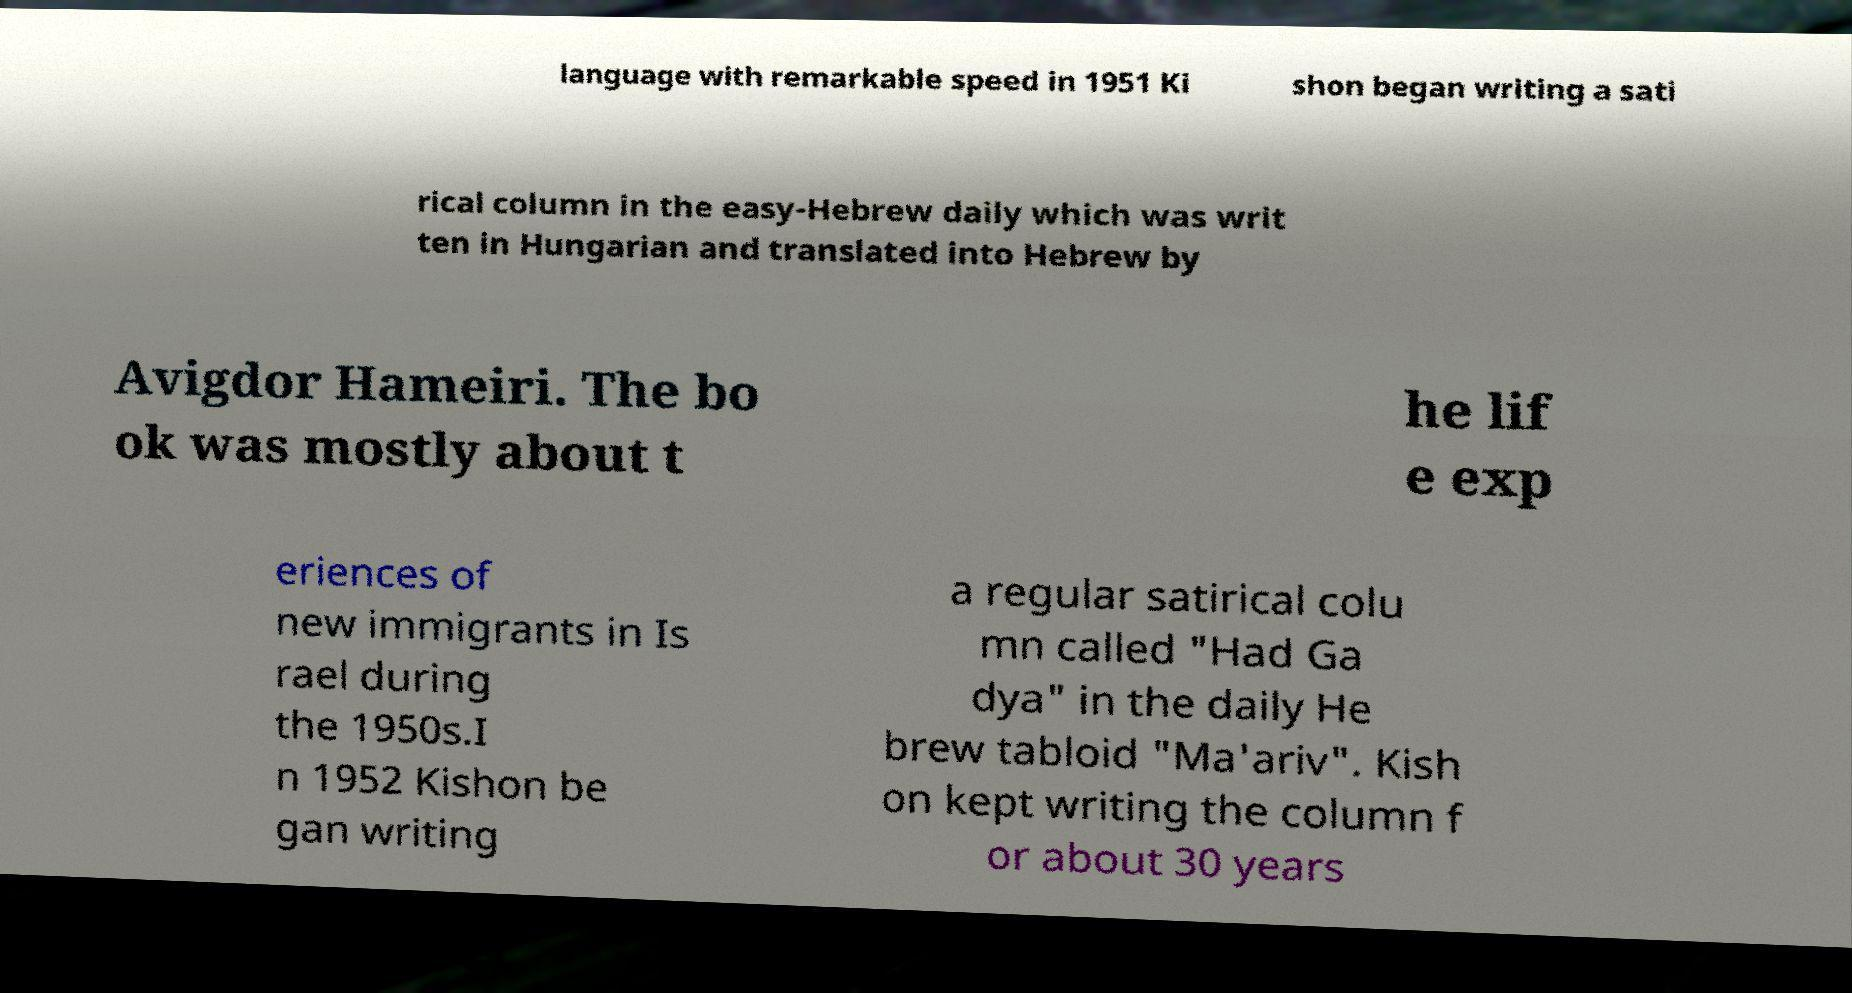What messages or text are displayed in this image? I need them in a readable, typed format. language with remarkable speed in 1951 Ki shon began writing a sati rical column in the easy-Hebrew daily which was writ ten in Hungarian and translated into Hebrew by Avigdor Hameiri. The bo ok was mostly about t he lif e exp eriences of new immigrants in Is rael during the 1950s.I n 1952 Kishon be gan writing a regular satirical colu mn called "Had Ga dya" in the daily He brew tabloid "Ma'ariv". Kish on kept writing the column f or about 30 years 